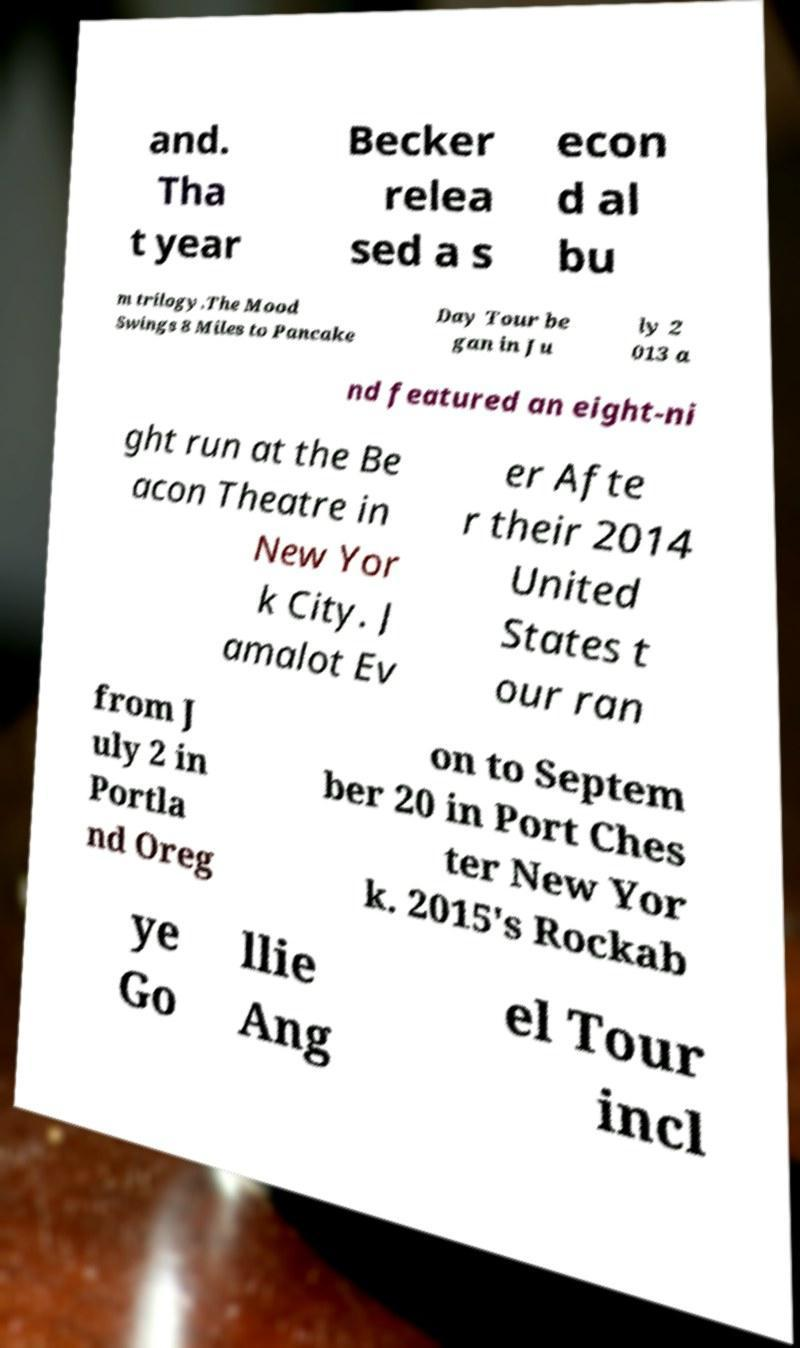I need the written content from this picture converted into text. Can you do that? and. Tha t year Becker relea sed a s econ d al bu m trilogy.The Mood Swings 8 Miles to Pancake Day Tour be gan in Ju ly 2 013 a nd featured an eight-ni ght run at the Be acon Theatre in New Yor k City. J amalot Ev er Afte r their 2014 United States t our ran from J uly 2 in Portla nd Oreg on to Septem ber 20 in Port Ches ter New Yor k. 2015's Rockab ye Go llie Ang el Tour incl 